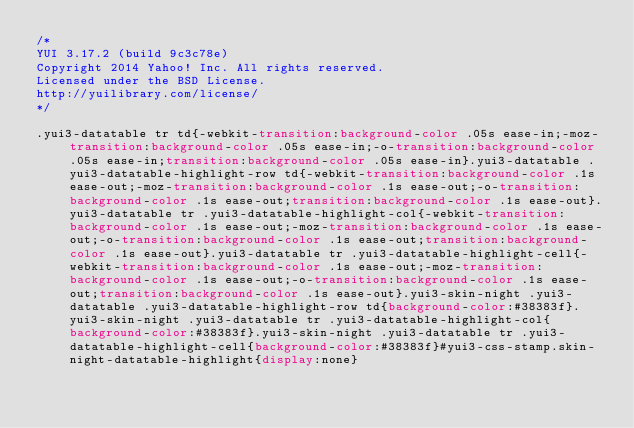Convert code to text. <code><loc_0><loc_0><loc_500><loc_500><_CSS_>/*
YUI 3.17.2 (build 9c3c78e)
Copyright 2014 Yahoo! Inc. All rights reserved.
Licensed under the BSD License.
http://yuilibrary.com/license/
*/

.yui3-datatable tr td{-webkit-transition:background-color .05s ease-in;-moz-transition:background-color .05s ease-in;-o-transition:background-color .05s ease-in;transition:background-color .05s ease-in}.yui3-datatable .yui3-datatable-highlight-row td{-webkit-transition:background-color .1s ease-out;-moz-transition:background-color .1s ease-out;-o-transition:background-color .1s ease-out;transition:background-color .1s ease-out}.yui3-datatable tr .yui3-datatable-highlight-col{-webkit-transition:background-color .1s ease-out;-moz-transition:background-color .1s ease-out;-o-transition:background-color .1s ease-out;transition:background-color .1s ease-out}.yui3-datatable tr .yui3-datatable-highlight-cell{-webkit-transition:background-color .1s ease-out;-moz-transition:background-color .1s ease-out;-o-transition:background-color .1s ease-out;transition:background-color .1s ease-out}.yui3-skin-night .yui3-datatable .yui3-datatable-highlight-row td{background-color:#38383f}.yui3-skin-night .yui3-datatable tr .yui3-datatable-highlight-col{background-color:#38383f}.yui3-skin-night .yui3-datatable tr .yui3-datatable-highlight-cell{background-color:#38383f}#yui3-css-stamp.skin-night-datatable-highlight{display:none}
</code> 